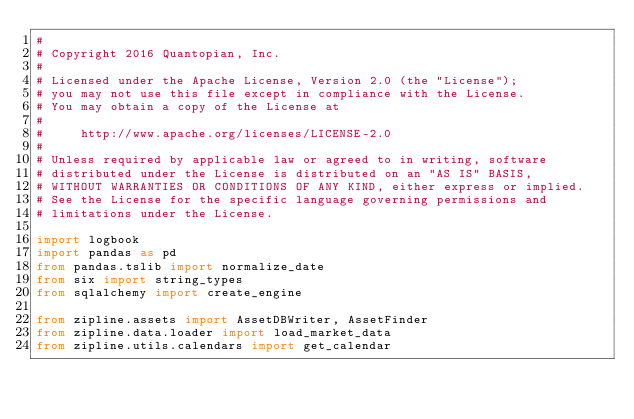<code> <loc_0><loc_0><loc_500><loc_500><_Python_>#
# Copyright 2016 Quantopian, Inc.
#
# Licensed under the Apache License, Version 2.0 (the "License");
# you may not use this file except in compliance with the License.
# You may obtain a copy of the License at
#
#     http://www.apache.org/licenses/LICENSE-2.0
#
# Unless required by applicable law or agreed to in writing, software
# distributed under the License is distributed on an "AS IS" BASIS,
# WITHOUT WARRANTIES OR CONDITIONS OF ANY KIND, either express or implied.
# See the License for the specific language governing permissions and
# limitations under the License.

import logbook
import pandas as pd
from pandas.tslib import normalize_date
from six import string_types
from sqlalchemy import create_engine

from zipline.assets import AssetDBWriter, AssetFinder
from zipline.data.loader import load_market_data
from zipline.utils.calendars import get_calendar</code> 